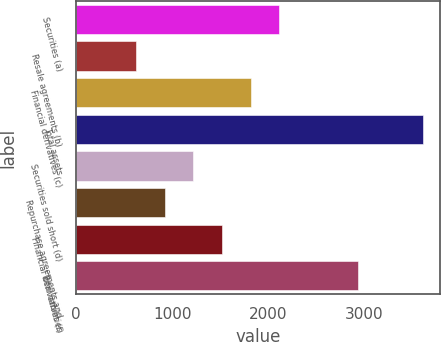<chart> <loc_0><loc_0><loc_500><loc_500><bar_chart><fcel>Securities (a)<fcel>Resale agreements (b)<fcel>Financial derivatives (c)<fcel>Total assets<fcel>Securities sold short (d)<fcel>Repurchase agreements and<fcel>Financial derivatives (f)<fcel>Total liabilities<nl><fcel>2117<fcel>623<fcel>1818.2<fcel>3611<fcel>1220.6<fcel>921.8<fcel>1519.4<fcel>2932<nl></chart> 